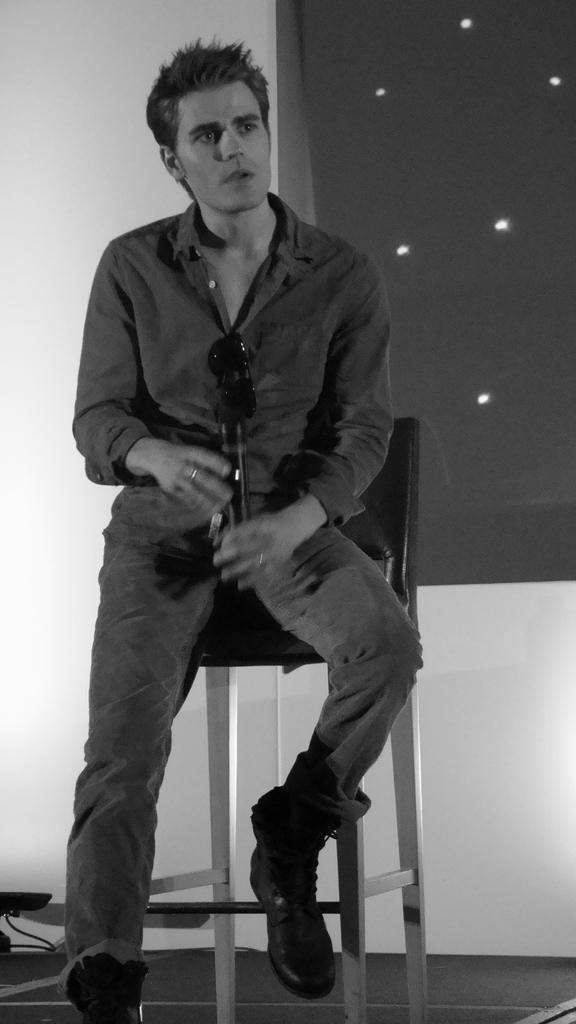What is the person in the image doing? The person is sitting on a chair and holding a microphone in their hand. What can be seen in the background of the image? There is a wall and a window in the background of the image. Where might this image have been taken? The image may have been taken in a hall, based on the presence of a wall and a window. What type of pin is the person wearing on their shirt in the image? There is no pin visible on the person's shirt in the image. What industry does the person in the image work in? The image does not provide any information about the person's occupation or industry. 